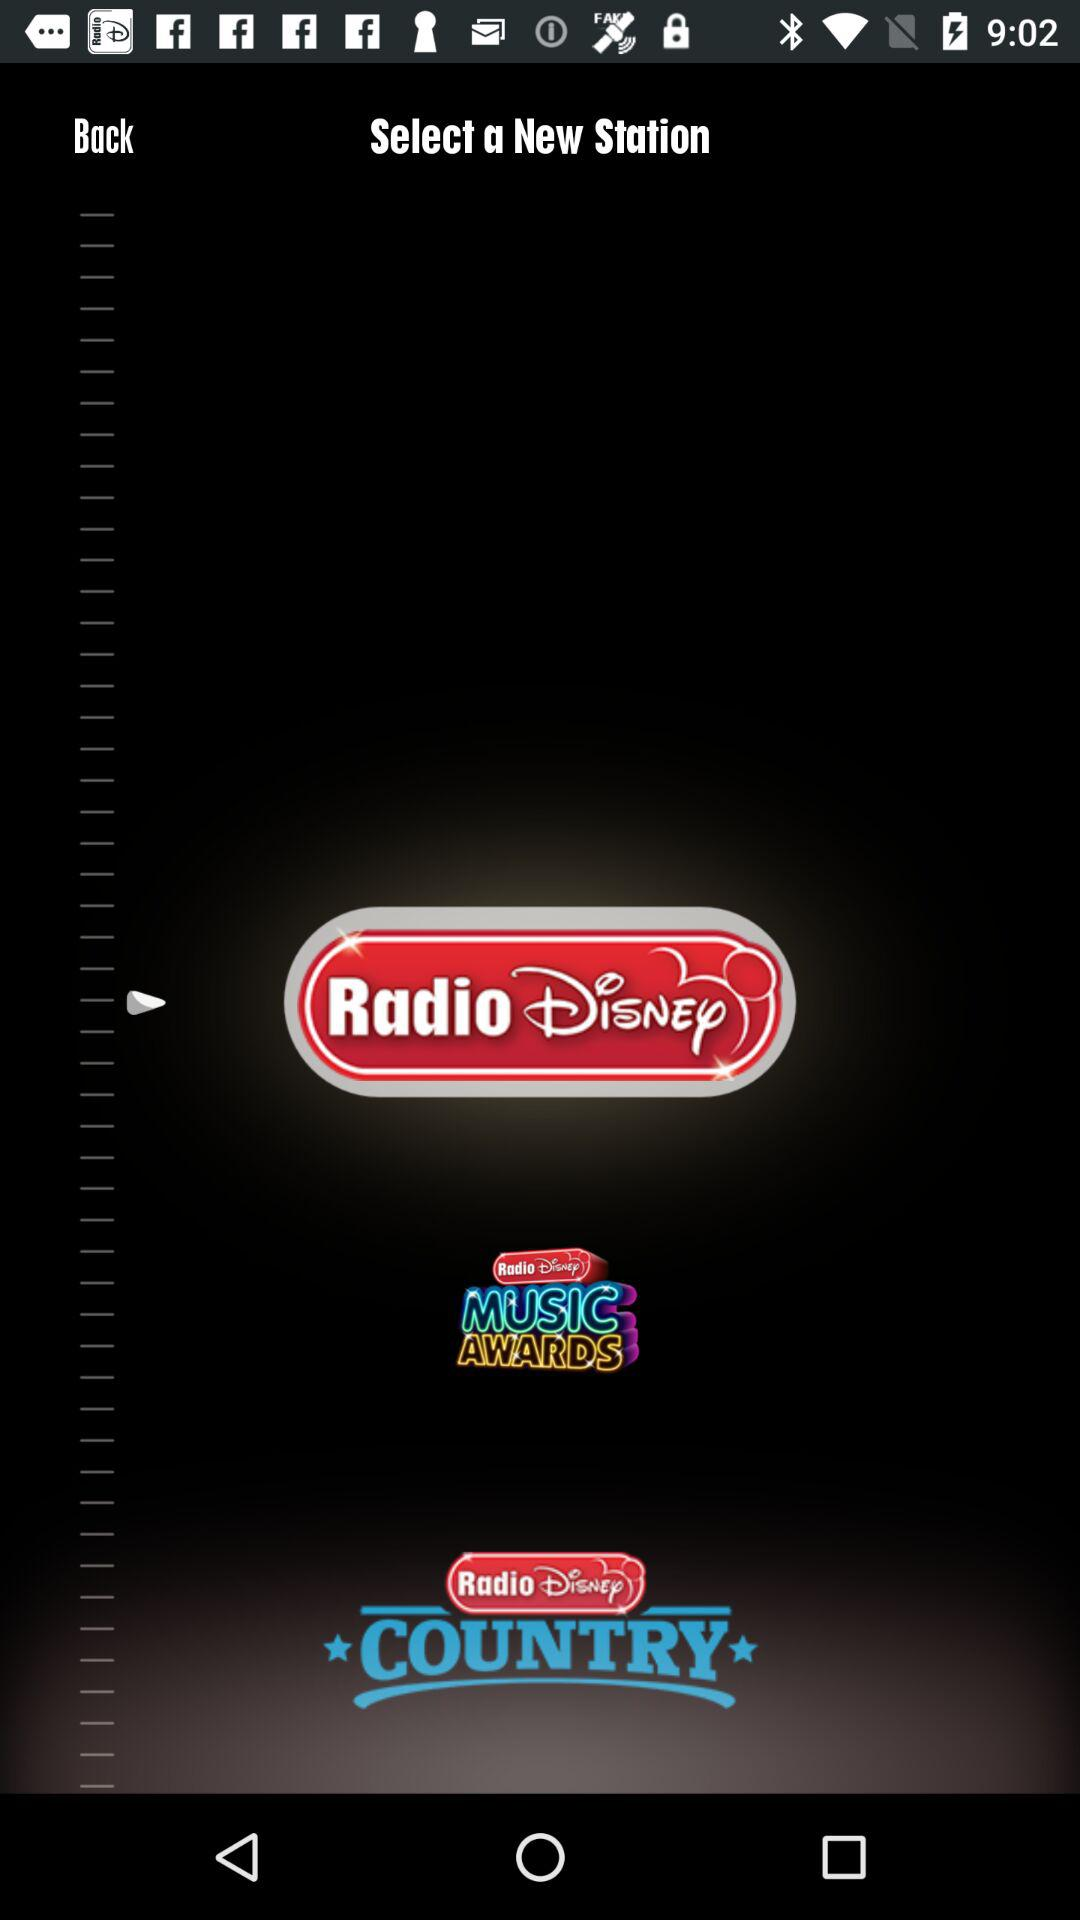Which new station is selected? The selected new station is Radio Disney. 